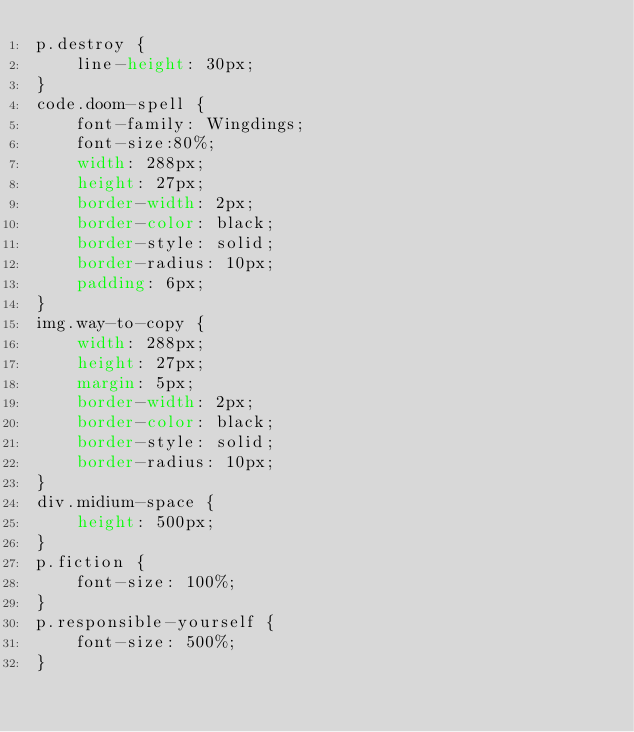Convert code to text. <code><loc_0><loc_0><loc_500><loc_500><_CSS_>p.destroy {
    line-height: 30px;
}
code.doom-spell {
    font-family: Wingdings;
    font-size:80%;
    width: 288px;
    height: 27px;
    border-width: 2px;
    border-color: black;
    border-style: solid;
    border-radius: 10px;
    padding: 6px;
}
img.way-to-copy {
    width: 288px;
    height: 27px;
    margin: 5px;
    border-width: 2px;
    border-color: black;
    border-style: solid;
    border-radius: 10px;
}
div.midium-space {
    height: 500px;
}
p.fiction {
    font-size: 100%;
}
p.responsible-yourself {
    font-size: 500%;
}</code> 